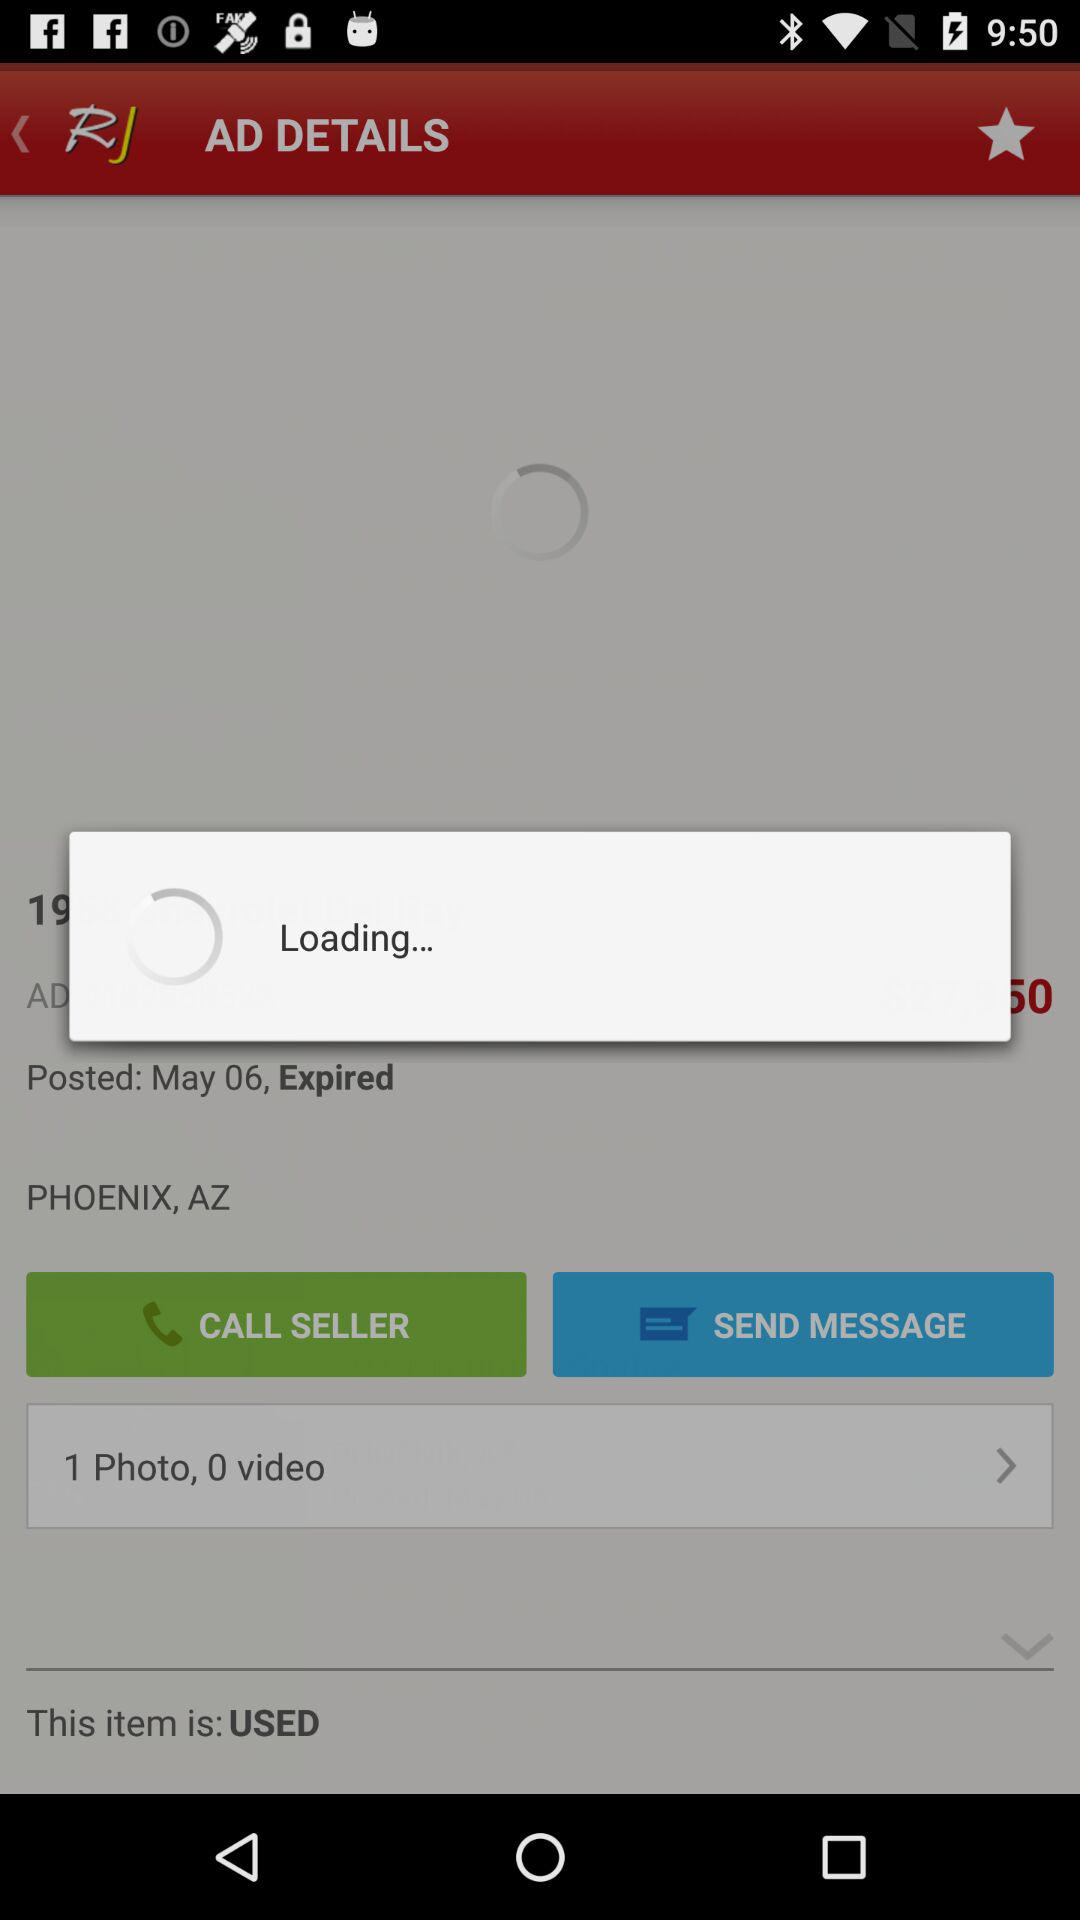How many more photos than videos are there in the ad?
Answer the question using a single word or phrase. 1 